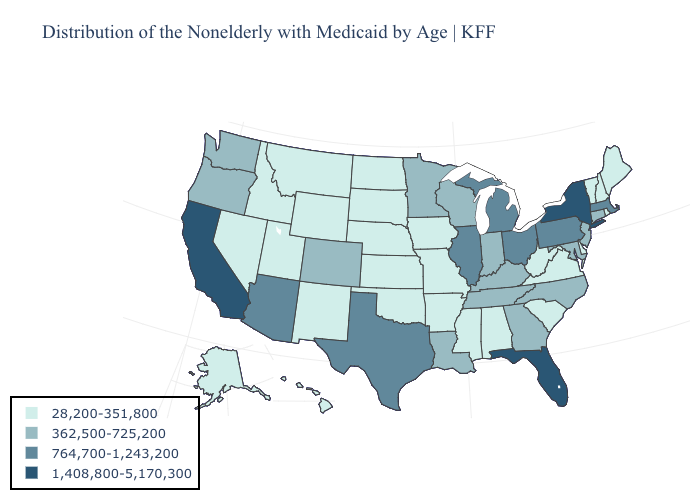Which states have the highest value in the USA?
Keep it brief. California, Florida, New York. What is the lowest value in states that border Illinois?
Write a very short answer. 28,200-351,800. Does South Carolina have the lowest value in the South?
Be succinct. Yes. Which states have the lowest value in the USA?
Short answer required. Alabama, Alaska, Arkansas, Delaware, Hawaii, Idaho, Iowa, Kansas, Maine, Mississippi, Missouri, Montana, Nebraska, Nevada, New Hampshire, New Mexico, North Dakota, Oklahoma, Rhode Island, South Carolina, South Dakota, Utah, Vermont, Virginia, West Virginia, Wyoming. Name the states that have a value in the range 764,700-1,243,200?
Quick response, please. Arizona, Illinois, Massachusetts, Michigan, Ohio, Pennsylvania, Texas. Among the states that border Connecticut , does Rhode Island have the highest value?
Short answer required. No. Does Alabama have the lowest value in the USA?
Be succinct. Yes. Among the states that border Wisconsin , does Michigan have the highest value?
Keep it brief. Yes. Which states have the lowest value in the Northeast?
Keep it brief. Maine, New Hampshire, Rhode Island, Vermont. What is the value of Texas?
Keep it brief. 764,700-1,243,200. Among the states that border Ohio , does West Virginia have the lowest value?
Answer briefly. Yes. Among the states that border North Carolina , does Virginia have the highest value?
Give a very brief answer. No. Which states hav the highest value in the South?
Quick response, please. Florida. What is the highest value in the MidWest ?
Be succinct. 764,700-1,243,200. 